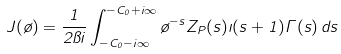<formula> <loc_0><loc_0><loc_500><loc_500>J ( \tau ) = \frac { 1 } { 2 \pi i } \int _ { - C _ { 0 } - i \infty } ^ { - C _ { 0 } + i \infty } \tau ^ { - s } Z _ { P } ( s ) \zeta ( s + 1 ) \Gamma ( s ) \, d s</formula> 